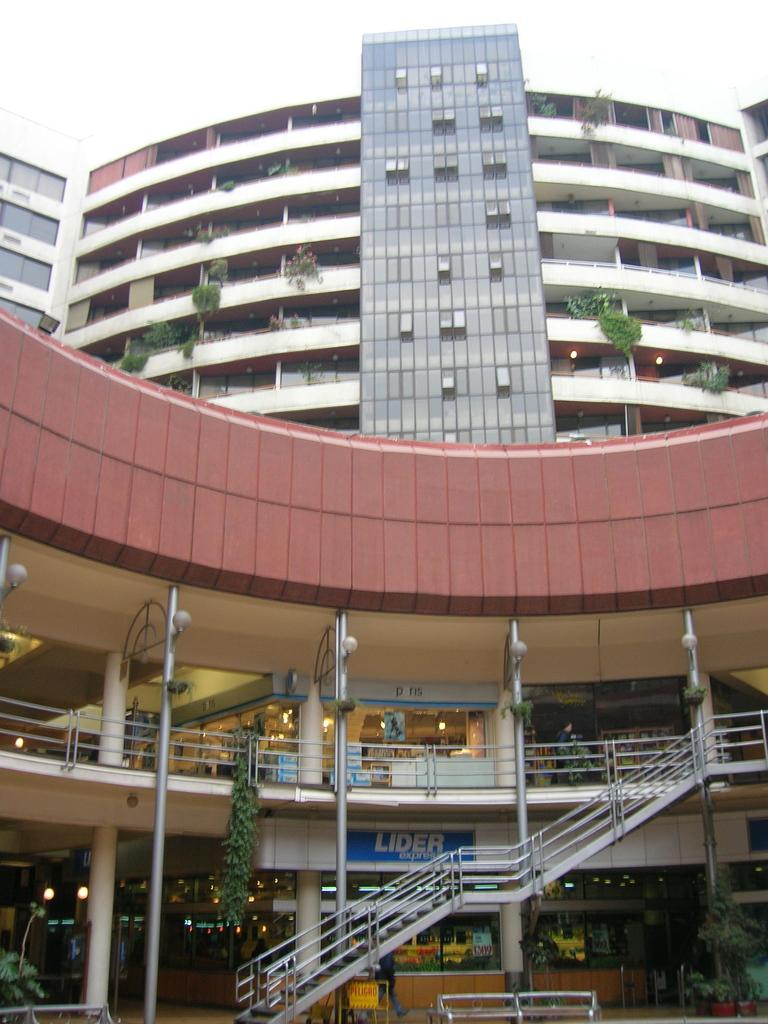<image>
Offer a succinct explanation of the picture presented. The front of an outside shopping mall with the name Lider on the bottom floor 